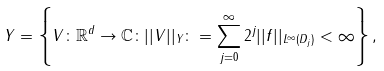Convert formula to latex. <formula><loc_0><loc_0><loc_500><loc_500>Y = \left \{ V \colon \mathbb { R } ^ { d } \to \mathbb { C } \colon | | V | | _ { Y } \colon = \sum _ { j = 0 } ^ { \infty } 2 ^ { j } | | f | | _ { L ^ { \infty } ( D _ { j } ) } < \infty \right \} ,</formula> 